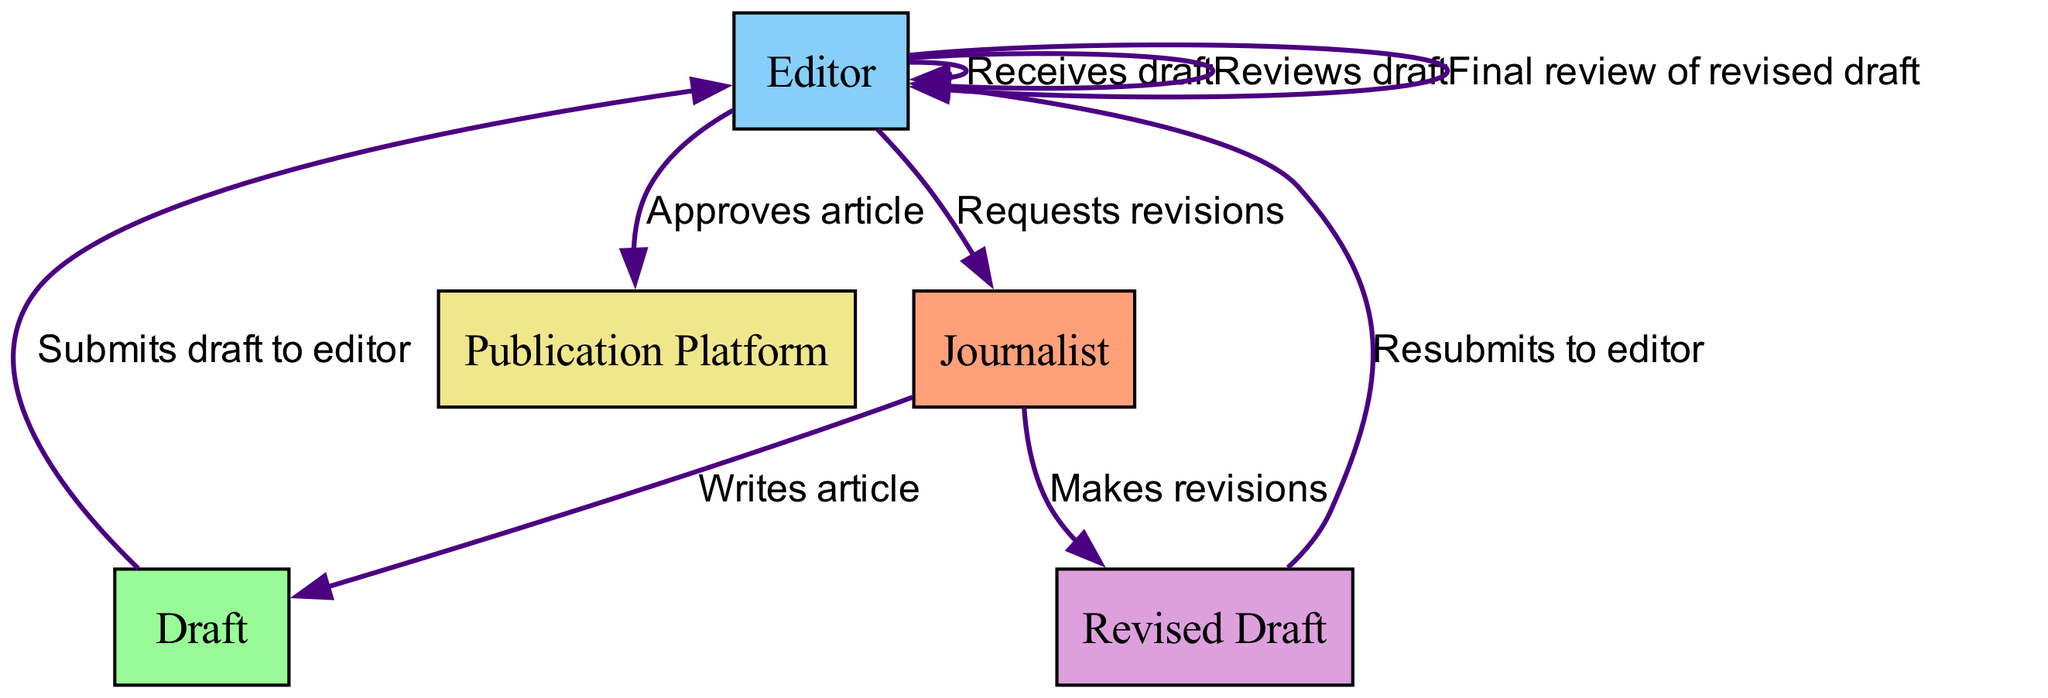What is the first action performed in the process? The first action is when the Journalist writes an article. This is the starting point of the sequence diagram, indicating the initial step in the submission process.
Answer: Writes article Who receives the draft after submission? After the journalist submits the draft, the Editor receives it. This relationship is a direct connection represented in the diagram, showing the flow from the Journalist to the Editor.
Answer: Receives draft How many revisions can be requested by the Editor? The Editor can request revisions only once according to the sequence of actions shown in the diagram. This is indicated by a single action labeled as "Requests revisions."
Answer: One What follows after the revisions are made by the Journalist? After the Journalist makes revisions, the next step is the resubmission of the Revised Draft to the editor. This is indicated by the flow in the diagram that connects the two actions.
Answer: Resubmits to editor Which entity is responsible for the final approval? The Editor is responsible for the final approval of the article, as shown in the sequence where the Editor's action leads to another step for article approval.
Answer: Approves article What type of document is submitted to the Editor for review? The document submitted is a Draft. This detail is explicitly mentioned in the flow of actions leading from the Journalist to the Editor.
Answer: Draft Which stage comes right before the article is published? The stage right before publication is the Approval of the article by the Editor. This is shown as a prerequisite step before the final action of publishing.
Answer: Approves article What does the Publication Platform do once the article is approved? The Publication Platform publishes the approved article. The final action in the sequence diagram indicates the flow leading to this step, completing the submission process.
Answer: Publishes approved article 